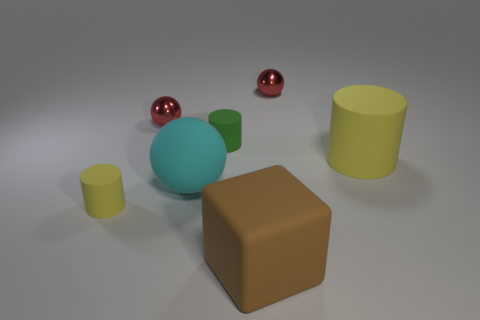Subtract all rubber balls. How many balls are left? 2 Add 3 large cyan objects. How many objects exist? 10 Subtract all red balls. How many balls are left? 1 Subtract all yellow cubes. How many yellow cylinders are left? 2 Subtract 1 balls. How many balls are left? 2 Subtract all purple spheres. Subtract all brown blocks. How many spheres are left? 3 Subtract all rubber cylinders. Subtract all tiny yellow matte cylinders. How many objects are left? 3 Add 7 matte spheres. How many matte spheres are left? 8 Add 2 big yellow cylinders. How many big yellow cylinders exist? 3 Subtract 0 yellow balls. How many objects are left? 7 